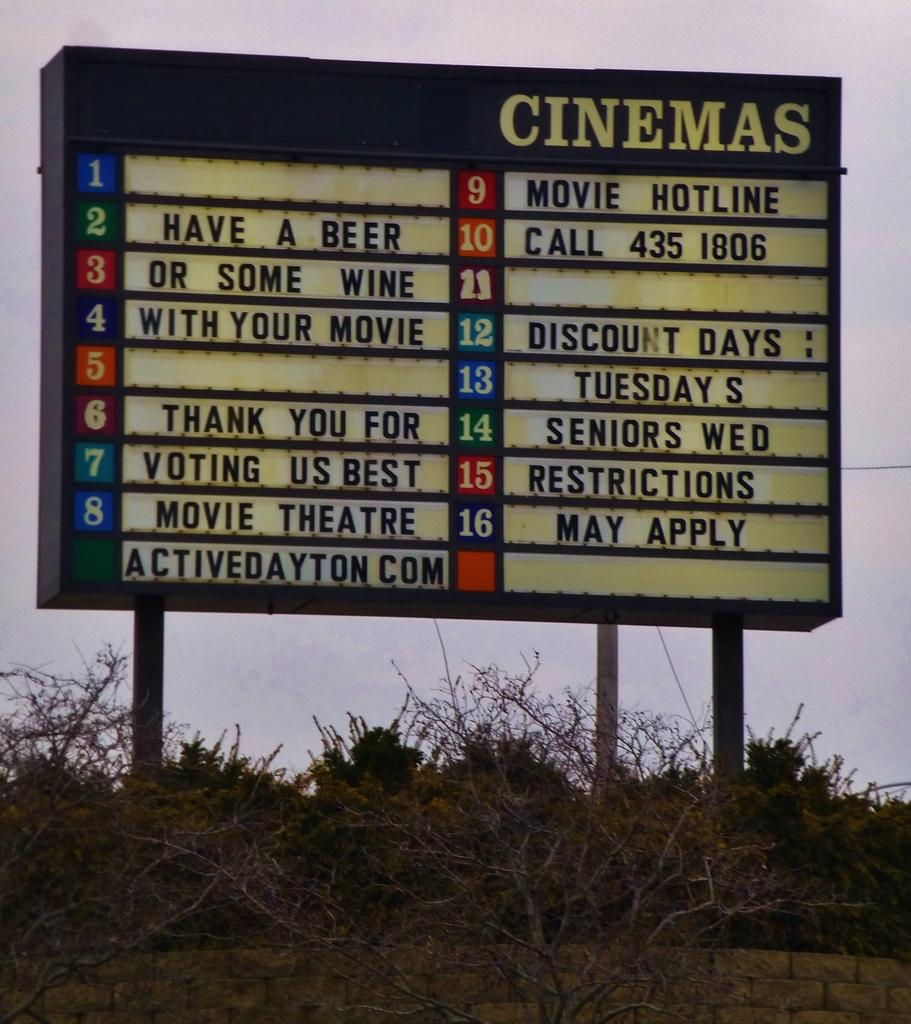<image>
Present a compact description of the photo's key features. a cinema sign with Have a Beer written on it 